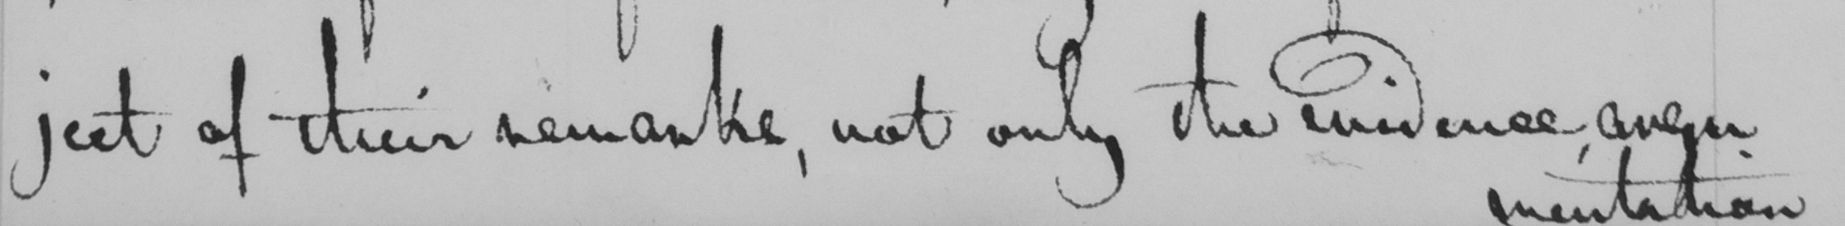Please transcribe the handwritten text in this image. ject of their remarks , not only the evidence even 